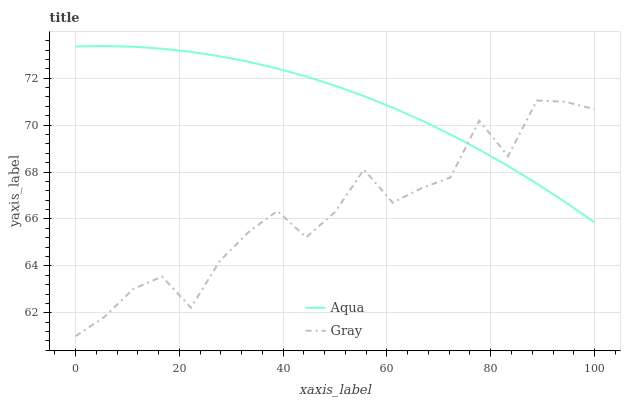Does Gray have the minimum area under the curve?
Answer yes or no. Yes. Does Aqua have the maximum area under the curve?
Answer yes or no. Yes. Does Aqua have the minimum area under the curve?
Answer yes or no. No. Is Aqua the smoothest?
Answer yes or no. Yes. Is Gray the roughest?
Answer yes or no. Yes. Is Aqua the roughest?
Answer yes or no. No. Does Gray have the lowest value?
Answer yes or no. Yes. Does Aqua have the lowest value?
Answer yes or no. No. Does Aqua have the highest value?
Answer yes or no. Yes. Does Aqua intersect Gray?
Answer yes or no. Yes. Is Aqua less than Gray?
Answer yes or no. No. Is Aqua greater than Gray?
Answer yes or no. No. 